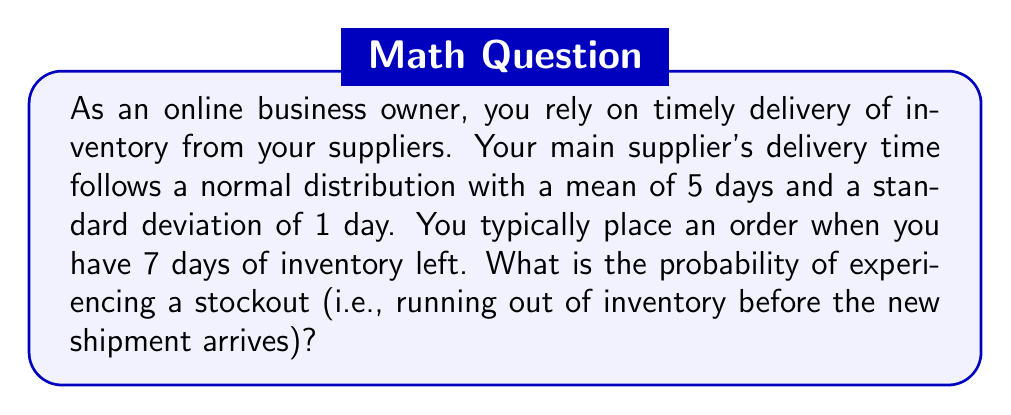Can you solve this math problem? To solve this problem, we need to follow these steps:

1) First, we need to understand what conditions lead to a stockout. A stockout occurs when the delivery time exceeds the remaining inventory days. In this case, a stockout happens if the delivery takes more than 7 days.

2) We're given that the delivery time follows a normal distribution with:
   $\mu = 5$ days (mean)
   $\sigma = 1$ day (standard deviation)

3) We want to find the probability that the delivery time is greater than 7 days. We can use the standard normal distribution (Z-score) to calculate this.

4) The Z-score formula is:

   $$Z = \frac{X - \mu}{\sigma}$$

   Where X is the value we're interested in (7 days in this case).

5) Plugging in our values:

   $$Z = \frac{7 - 5}{1} = 2$$

6) Now we need to find P(Z > 2), which is the area under the standard normal curve to the right of Z = 2.

7) Using a standard normal table or calculator, we can find that:

   P(Z > 2) ≈ 0.0228

This means there's approximately a 2.28% chance that the delivery will take longer than 7 days, resulting in a stockout.
Answer: The probability of experiencing a stockout is approximately 0.0228 or 2.28%. 